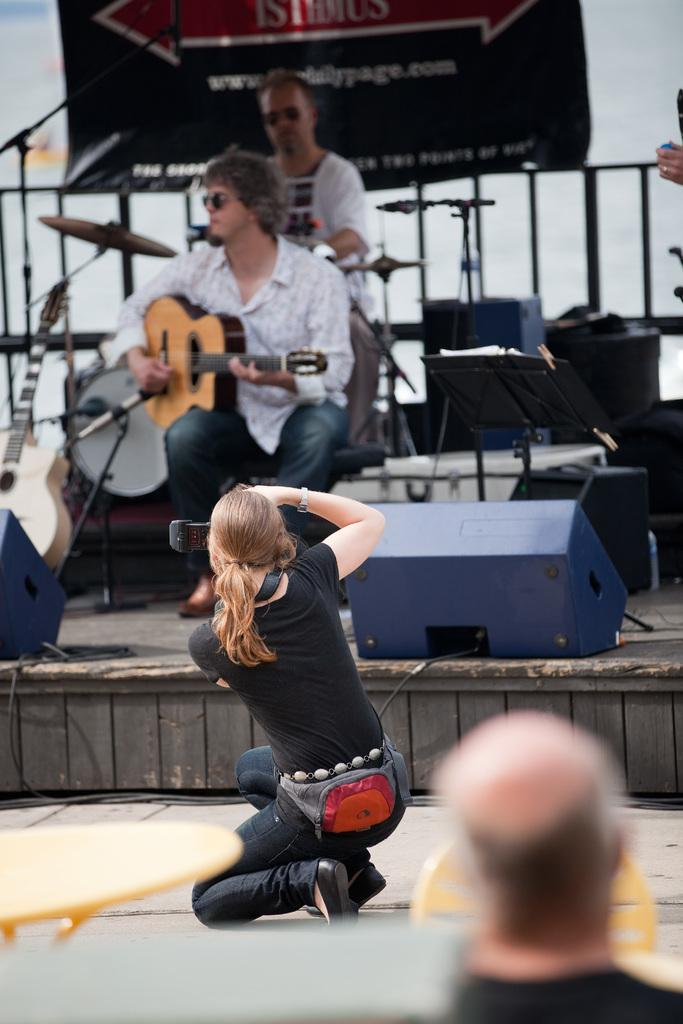How many people are in the image? There are people in the image, but the exact number is not specified. What is one person doing in the image? One man is playing a guitar in the image. What position is the woman in the image? There is a woman in a sitting position in the image. What can be seen in the background of the image? There is a banner in the background of the image. What type of grain is being harvested in the image? There is no grain or harvesting activity present in the image. What agreement was reached between the people in the image? The facts provided do not mention any agreement or discussion between the people in the image. 